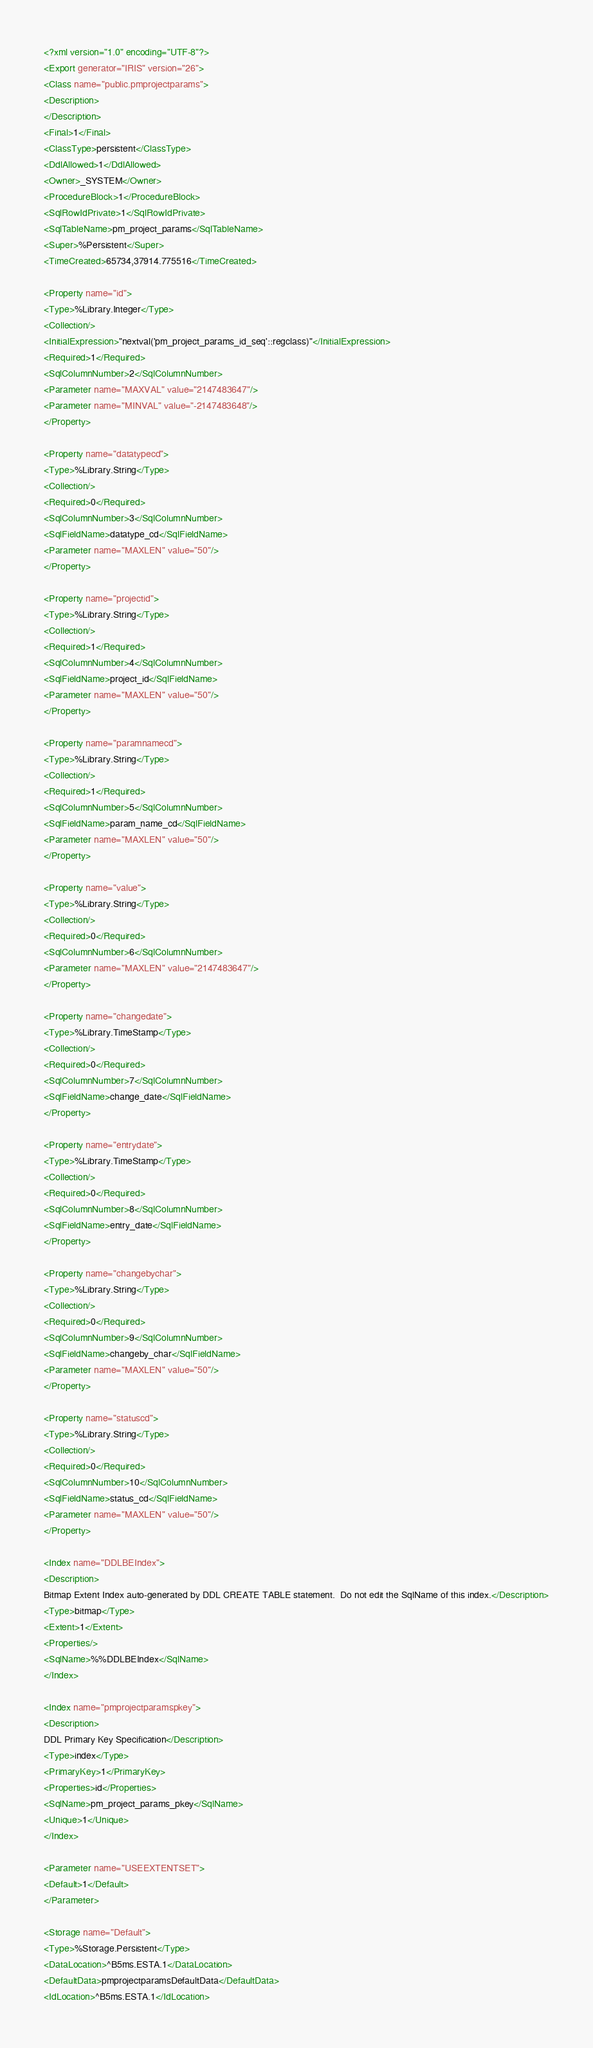<code> <loc_0><loc_0><loc_500><loc_500><_XML_><?xml version="1.0" encoding="UTF-8"?>
<Export generator="IRIS" version="26">
<Class name="public.pmprojectparams">
<Description>
</Description>
<Final>1</Final>
<ClassType>persistent</ClassType>
<DdlAllowed>1</DdlAllowed>
<Owner>_SYSTEM</Owner>
<ProcedureBlock>1</ProcedureBlock>
<SqlRowIdPrivate>1</SqlRowIdPrivate>
<SqlTableName>pm_project_params</SqlTableName>
<Super>%Persistent</Super>
<TimeCreated>65734,37914.775516</TimeCreated>

<Property name="id">
<Type>%Library.Integer</Type>
<Collection/>
<InitialExpression>"nextval('pm_project_params_id_seq'::regclass)"</InitialExpression>
<Required>1</Required>
<SqlColumnNumber>2</SqlColumnNumber>
<Parameter name="MAXVAL" value="2147483647"/>
<Parameter name="MINVAL" value="-2147483648"/>
</Property>

<Property name="datatypecd">
<Type>%Library.String</Type>
<Collection/>
<Required>0</Required>
<SqlColumnNumber>3</SqlColumnNumber>
<SqlFieldName>datatype_cd</SqlFieldName>
<Parameter name="MAXLEN" value="50"/>
</Property>

<Property name="projectid">
<Type>%Library.String</Type>
<Collection/>
<Required>1</Required>
<SqlColumnNumber>4</SqlColumnNumber>
<SqlFieldName>project_id</SqlFieldName>
<Parameter name="MAXLEN" value="50"/>
</Property>

<Property name="paramnamecd">
<Type>%Library.String</Type>
<Collection/>
<Required>1</Required>
<SqlColumnNumber>5</SqlColumnNumber>
<SqlFieldName>param_name_cd</SqlFieldName>
<Parameter name="MAXLEN" value="50"/>
</Property>

<Property name="value">
<Type>%Library.String</Type>
<Collection/>
<Required>0</Required>
<SqlColumnNumber>6</SqlColumnNumber>
<Parameter name="MAXLEN" value="2147483647"/>
</Property>

<Property name="changedate">
<Type>%Library.TimeStamp</Type>
<Collection/>
<Required>0</Required>
<SqlColumnNumber>7</SqlColumnNumber>
<SqlFieldName>change_date</SqlFieldName>
</Property>

<Property name="entrydate">
<Type>%Library.TimeStamp</Type>
<Collection/>
<Required>0</Required>
<SqlColumnNumber>8</SqlColumnNumber>
<SqlFieldName>entry_date</SqlFieldName>
</Property>

<Property name="changebychar">
<Type>%Library.String</Type>
<Collection/>
<Required>0</Required>
<SqlColumnNumber>9</SqlColumnNumber>
<SqlFieldName>changeby_char</SqlFieldName>
<Parameter name="MAXLEN" value="50"/>
</Property>

<Property name="statuscd">
<Type>%Library.String</Type>
<Collection/>
<Required>0</Required>
<SqlColumnNumber>10</SqlColumnNumber>
<SqlFieldName>status_cd</SqlFieldName>
<Parameter name="MAXLEN" value="50"/>
</Property>

<Index name="DDLBEIndex">
<Description>
Bitmap Extent Index auto-generated by DDL CREATE TABLE statement.  Do not edit the SqlName of this index.</Description>
<Type>bitmap</Type>
<Extent>1</Extent>
<Properties/>
<SqlName>%%DDLBEIndex</SqlName>
</Index>

<Index name="pmprojectparamspkey">
<Description>
DDL Primary Key Specification</Description>
<Type>index</Type>
<PrimaryKey>1</PrimaryKey>
<Properties>id</Properties>
<SqlName>pm_project_params_pkey</SqlName>
<Unique>1</Unique>
</Index>

<Parameter name="USEEXTENTSET">
<Default>1</Default>
</Parameter>

<Storage name="Default">
<Type>%Storage.Persistent</Type>
<DataLocation>^B5ms.ESTA.1</DataLocation>
<DefaultData>pmprojectparamsDefaultData</DefaultData>
<IdLocation>^B5ms.ESTA.1</IdLocation></code> 